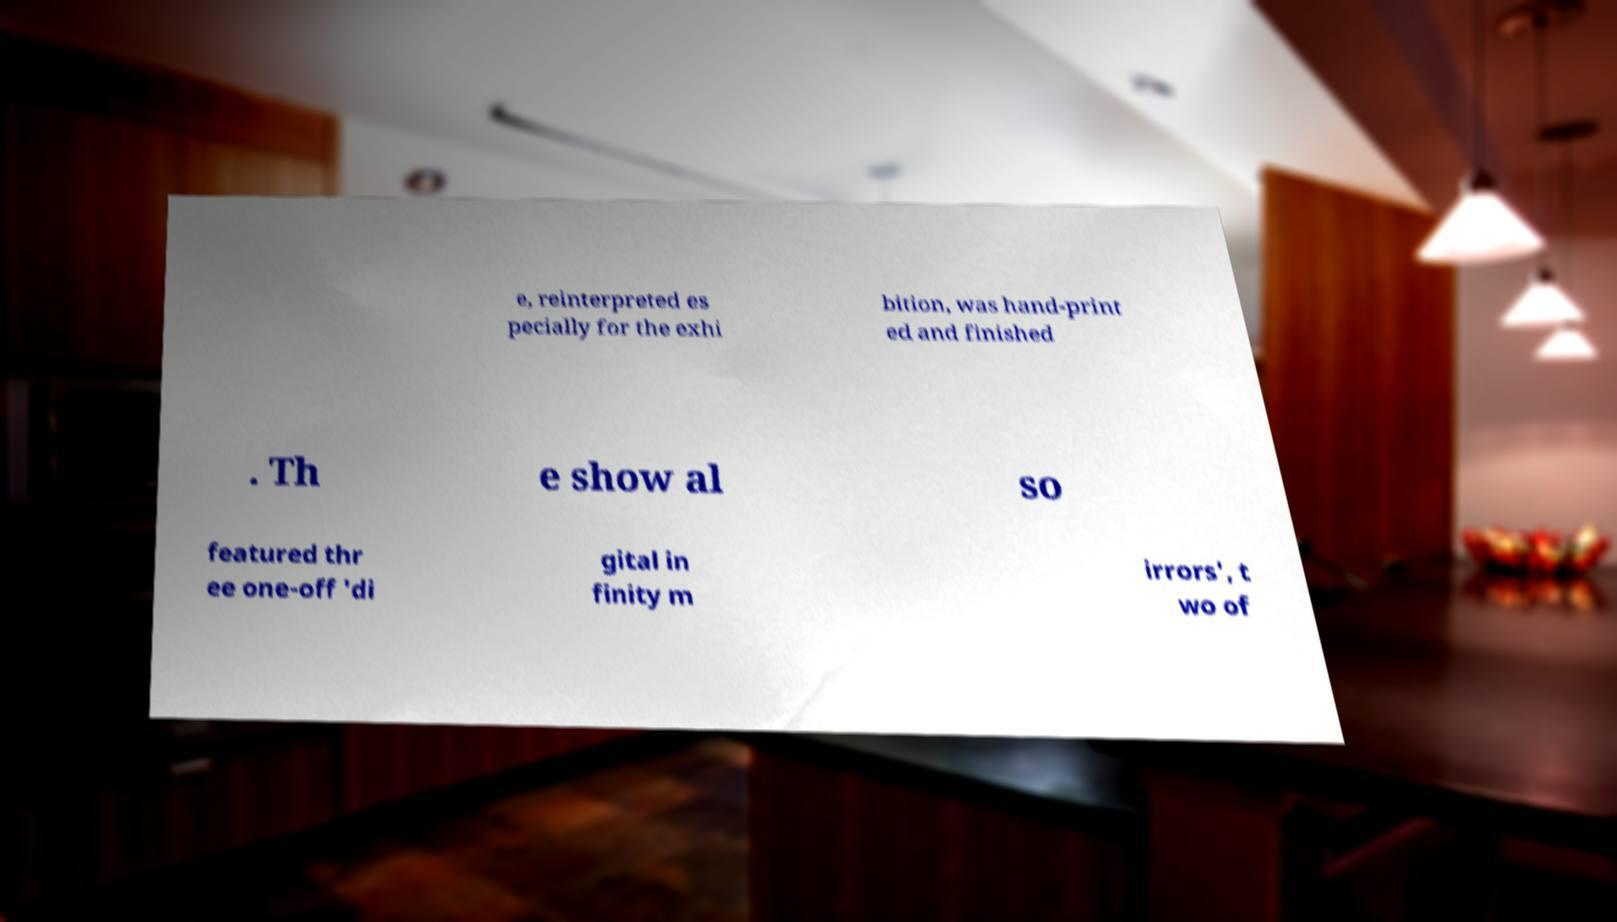What messages or text are displayed in this image? I need them in a readable, typed format. e, reinterpreted es pecially for the exhi bition, was hand-print ed and finished . Th e show al so featured thr ee one-off 'di gital in finity m irrors', t wo of 